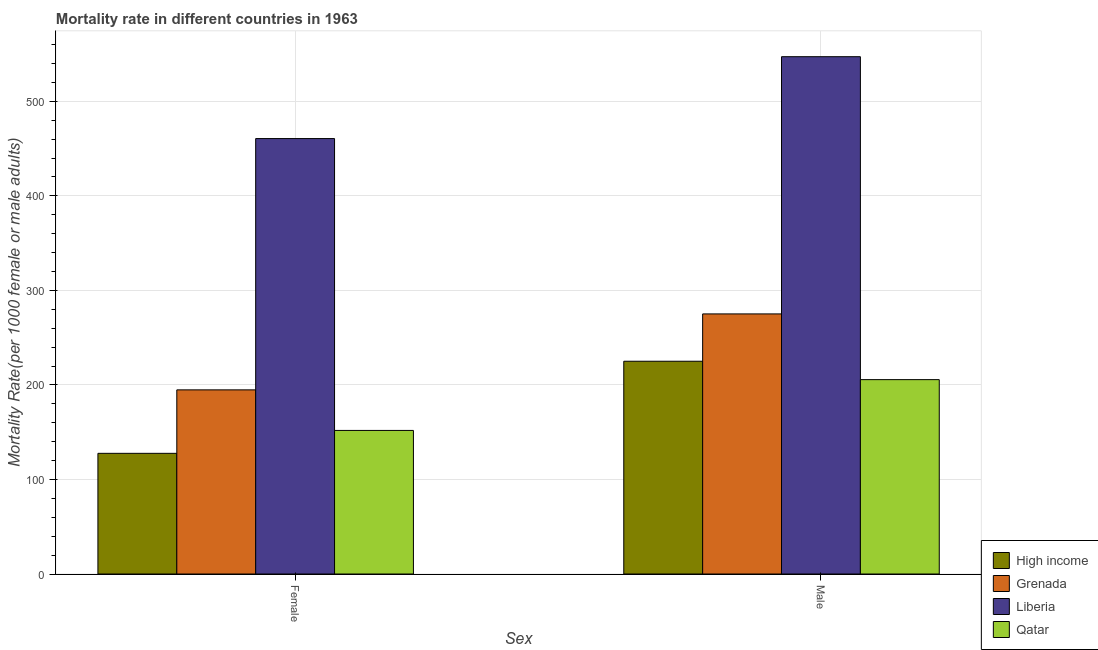How many groups of bars are there?
Keep it short and to the point. 2. Are the number of bars per tick equal to the number of legend labels?
Ensure brevity in your answer.  Yes. Are the number of bars on each tick of the X-axis equal?
Provide a succinct answer. Yes. How many bars are there on the 1st tick from the left?
Keep it short and to the point. 4. What is the label of the 2nd group of bars from the left?
Offer a very short reply. Male. What is the male mortality rate in Qatar?
Give a very brief answer. 205.62. Across all countries, what is the maximum male mortality rate?
Provide a short and direct response. 547.23. Across all countries, what is the minimum female mortality rate?
Provide a short and direct response. 127.64. In which country was the female mortality rate maximum?
Offer a terse response. Liberia. What is the total female mortality rate in the graph?
Your response must be concise. 934.92. What is the difference between the female mortality rate in Grenada and that in Qatar?
Your response must be concise. 42.92. What is the difference between the male mortality rate in Qatar and the female mortality rate in High income?
Make the answer very short. 77.98. What is the average male mortality rate per country?
Make the answer very short. 313.26. What is the difference between the female mortality rate and male mortality rate in Qatar?
Your answer should be very brief. -53.75. What is the ratio of the male mortality rate in Qatar to that in Liberia?
Your response must be concise. 0.38. Is the female mortality rate in Liberia less than that in Grenada?
Your response must be concise. No. In how many countries, is the female mortality rate greater than the average female mortality rate taken over all countries?
Give a very brief answer. 1. What does the 3rd bar from the left in Female represents?
Keep it short and to the point. Liberia. What does the 2nd bar from the right in Female represents?
Your answer should be compact. Liberia. How many bars are there?
Provide a short and direct response. 8. How many countries are there in the graph?
Provide a short and direct response. 4. What is the difference between two consecutive major ticks on the Y-axis?
Your answer should be very brief. 100. Are the values on the major ticks of Y-axis written in scientific E-notation?
Offer a terse response. No. Does the graph contain any zero values?
Give a very brief answer. No. Does the graph contain grids?
Give a very brief answer. Yes. Where does the legend appear in the graph?
Give a very brief answer. Bottom right. How many legend labels are there?
Offer a terse response. 4. How are the legend labels stacked?
Keep it short and to the point. Vertical. What is the title of the graph?
Ensure brevity in your answer.  Mortality rate in different countries in 1963. Does "Dominica" appear as one of the legend labels in the graph?
Your response must be concise. No. What is the label or title of the X-axis?
Provide a succinct answer. Sex. What is the label or title of the Y-axis?
Provide a short and direct response. Mortality Rate(per 1000 female or male adults). What is the Mortality Rate(per 1000 female or male adults) in High income in Female?
Offer a very short reply. 127.64. What is the Mortality Rate(per 1000 female or male adults) in Grenada in Female?
Your answer should be very brief. 194.79. What is the Mortality Rate(per 1000 female or male adults) in Liberia in Female?
Your response must be concise. 460.62. What is the Mortality Rate(per 1000 female or male adults) of Qatar in Female?
Give a very brief answer. 151.88. What is the Mortality Rate(per 1000 female or male adults) of High income in Male?
Your answer should be compact. 225.07. What is the Mortality Rate(per 1000 female or male adults) of Grenada in Male?
Your response must be concise. 275.13. What is the Mortality Rate(per 1000 female or male adults) in Liberia in Male?
Your answer should be very brief. 547.23. What is the Mortality Rate(per 1000 female or male adults) of Qatar in Male?
Offer a very short reply. 205.62. Across all Sex, what is the maximum Mortality Rate(per 1000 female or male adults) in High income?
Give a very brief answer. 225.07. Across all Sex, what is the maximum Mortality Rate(per 1000 female or male adults) in Grenada?
Offer a very short reply. 275.13. Across all Sex, what is the maximum Mortality Rate(per 1000 female or male adults) of Liberia?
Offer a very short reply. 547.23. Across all Sex, what is the maximum Mortality Rate(per 1000 female or male adults) of Qatar?
Provide a short and direct response. 205.62. Across all Sex, what is the minimum Mortality Rate(per 1000 female or male adults) of High income?
Provide a succinct answer. 127.64. Across all Sex, what is the minimum Mortality Rate(per 1000 female or male adults) in Grenada?
Ensure brevity in your answer.  194.79. Across all Sex, what is the minimum Mortality Rate(per 1000 female or male adults) in Liberia?
Ensure brevity in your answer.  460.62. Across all Sex, what is the minimum Mortality Rate(per 1000 female or male adults) in Qatar?
Make the answer very short. 151.88. What is the total Mortality Rate(per 1000 female or male adults) in High income in the graph?
Give a very brief answer. 352.71. What is the total Mortality Rate(per 1000 female or male adults) in Grenada in the graph?
Ensure brevity in your answer.  469.93. What is the total Mortality Rate(per 1000 female or male adults) of Liberia in the graph?
Offer a terse response. 1007.85. What is the total Mortality Rate(per 1000 female or male adults) of Qatar in the graph?
Your answer should be very brief. 357.5. What is the difference between the Mortality Rate(per 1000 female or male adults) in High income in Female and that in Male?
Your answer should be very brief. -97.43. What is the difference between the Mortality Rate(per 1000 female or male adults) of Grenada in Female and that in Male?
Give a very brief answer. -80.34. What is the difference between the Mortality Rate(per 1000 female or male adults) in Liberia in Female and that in Male?
Your answer should be very brief. -86.62. What is the difference between the Mortality Rate(per 1000 female or male adults) of Qatar in Female and that in Male?
Provide a succinct answer. -53.74. What is the difference between the Mortality Rate(per 1000 female or male adults) in High income in Female and the Mortality Rate(per 1000 female or male adults) in Grenada in Male?
Keep it short and to the point. -147.49. What is the difference between the Mortality Rate(per 1000 female or male adults) in High income in Female and the Mortality Rate(per 1000 female or male adults) in Liberia in Male?
Offer a very short reply. -419.59. What is the difference between the Mortality Rate(per 1000 female or male adults) in High income in Female and the Mortality Rate(per 1000 female or male adults) in Qatar in Male?
Keep it short and to the point. -77.98. What is the difference between the Mortality Rate(per 1000 female or male adults) in Grenada in Female and the Mortality Rate(per 1000 female or male adults) in Liberia in Male?
Keep it short and to the point. -352.44. What is the difference between the Mortality Rate(per 1000 female or male adults) of Grenada in Female and the Mortality Rate(per 1000 female or male adults) of Qatar in Male?
Offer a very short reply. -10.83. What is the difference between the Mortality Rate(per 1000 female or male adults) in Liberia in Female and the Mortality Rate(per 1000 female or male adults) in Qatar in Male?
Provide a succinct answer. 255. What is the average Mortality Rate(per 1000 female or male adults) in High income per Sex?
Offer a very short reply. 176.36. What is the average Mortality Rate(per 1000 female or male adults) of Grenada per Sex?
Provide a succinct answer. 234.96. What is the average Mortality Rate(per 1000 female or male adults) in Liberia per Sex?
Provide a short and direct response. 503.92. What is the average Mortality Rate(per 1000 female or male adults) of Qatar per Sex?
Provide a succinct answer. 178.75. What is the difference between the Mortality Rate(per 1000 female or male adults) in High income and Mortality Rate(per 1000 female or male adults) in Grenada in Female?
Keep it short and to the point. -67.15. What is the difference between the Mortality Rate(per 1000 female or male adults) in High income and Mortality Rate(per 1000 female or male adults) in Liberia in Female?
Your answer should be compact. -332.97. What is the difference between the Mortality Rate(per 1000 female or male adults) of High income and Mortality Rate(per 1000 female or male adults) of Qatar in Female?
Your answer should be very brief. -24.23. What is the difference between the Mortality Rate(per 1000 female or male adults) in Grenada and Mortality Rate(per 1000 female or male adults) in Liberia in Female?
Your answer should be very brief. -265.82. What is the difference between the Mortality Rate(per 1000 female or male adults) in Grenada and Mortality Rate(per 1000 female or male adults) in Qatar in Female?
Offer a very short reply. 42.92. What is the difference between the Mortality Rate(per 1000 female or male adults) in Liberia and Mortality Rate(per 1000 female or male adults) in Qatar in Female?
Your response must be concise. 308.74. What is the difference between the Mortality Rate(per 1000 female or male adults) of High income and Mortality Rate(per 1000 female or male adults) of Grenada in Male?
Offer a terse response. -50.06. What is the difference between the Mortality Rate(per 1000 female or male adults) in High income and Mortality Rate(per 1000 female or male adults) in Liberia in Male?
Your answer should be very brief. -322.16. What is the difference between the Mortality Rate(per 1000 female or male adults) in High income and Mortality Rate(per 1000 female or male adults) in Qatar in Male?
Provide a short and direct response. 19.45. What is the difference between the Mortality Rate(per 1000 female or male adults) in Grenada and Mortality Rate(per 1000 female or male adults) in Liberia in Male?
Your answer should be very brief. -272.1. What is the difference between the Mortality Rate(per 1000 female or male adults) of Grenada and Mortality Rate(per 1000 female or male adults) of Qatar in Male?
Provide a succinct answer. 69.52. What is the difference between the Mortality Rate(per 1000 female or male adults) in Liberia and Mortality Rate(per 1000 female or male adults) in Qatar in Male?
Make the answer very short. 341.61. What is the ratio of the Mortality Rate(per 1000 female or male adults) of High income in Female to that in Male?
Your answer should be very brief. 0.57. What is the ratio of the Mortality Rate(per 1000 female or male adults) in Grenada in Female to that in Male?
Ensure brevity in your answer.  0.71. What is the ratio of the Mortality Rate(per 1000 female or male adults) of Liberia in Female to that in Male?
Your answer should be compact. 0.84. What is the ratio of the Mortality Rate(per 1000 female or male adults) in Qatar in Female to that in Male?
Provide a succinct answer. 0.74. What is the difference between the highest and the second highest Mortality Rate(per 1000 female or male adults) of High income?
Ensure brevity in your answer.  97.43. What is the difference between the highest and the second highest Mortality Rate(per 1000 female or male adults) in Grenada?
Offer a terse response. 80.34. What is the difference between the highest and the second highest Mortality Rate(per 1000 female or male adults) of Liberia?
Make the answer very short. 86.62. What is the difference between the highest and the second highest Mortality Rate(per 1000 female or male adults) in Qatar?
Offer a very short reply. 53.74. What is the difference between the highest and the lowest Mortality Rate(per 1000 female or male adults) of High income?
Provide a succinct answer. 97.43. What is the difference between the highest and the lowest Mortality Rate(per 1000 female or male adults) in Grenada?
Offer a terse response. 80.34. What is the difference between the highest and the lowest Mortality Rate(per 1000 female or male adults) in Liberia?
Offer a very short reply. 86.62. What is the difference between the highest and the lowest Mortality Rate(per 1000 female or male adults) in Qatar?
Offer a terse response. 53.74. 